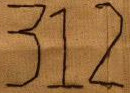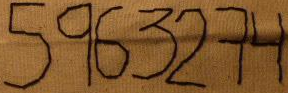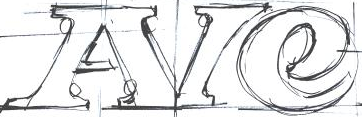Identify the words shown in these images in order, separated by a semicolon. 312; 5963274; AIe 